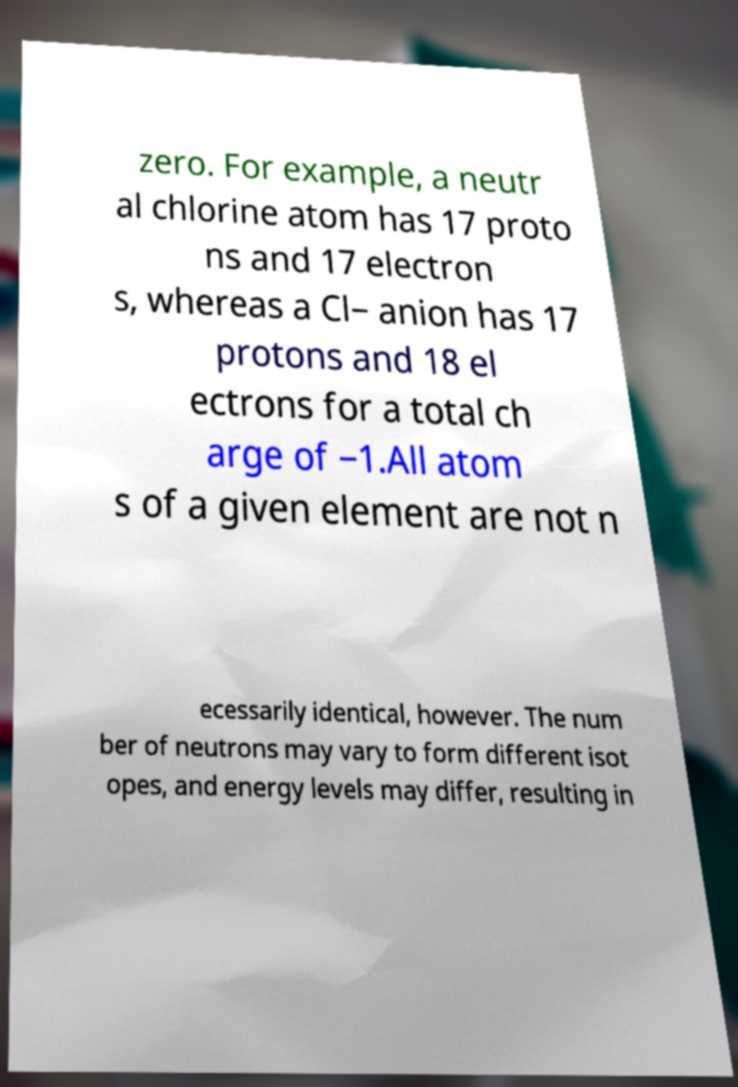There's text embedded in this image that I need extracted. Can you transcribe it verbatim? zero. For example, a neutr al chlorine atom has 17 proto ns and 17 electron s, whereas a Cl− anion has 17 protons and 18 el ectrons for a total ch arge of −1.All atom s of a given element are not n ecessarily identical, however. The num ber of neutrons may vary to form different isot opes, and energy levels may differ, resulting in 